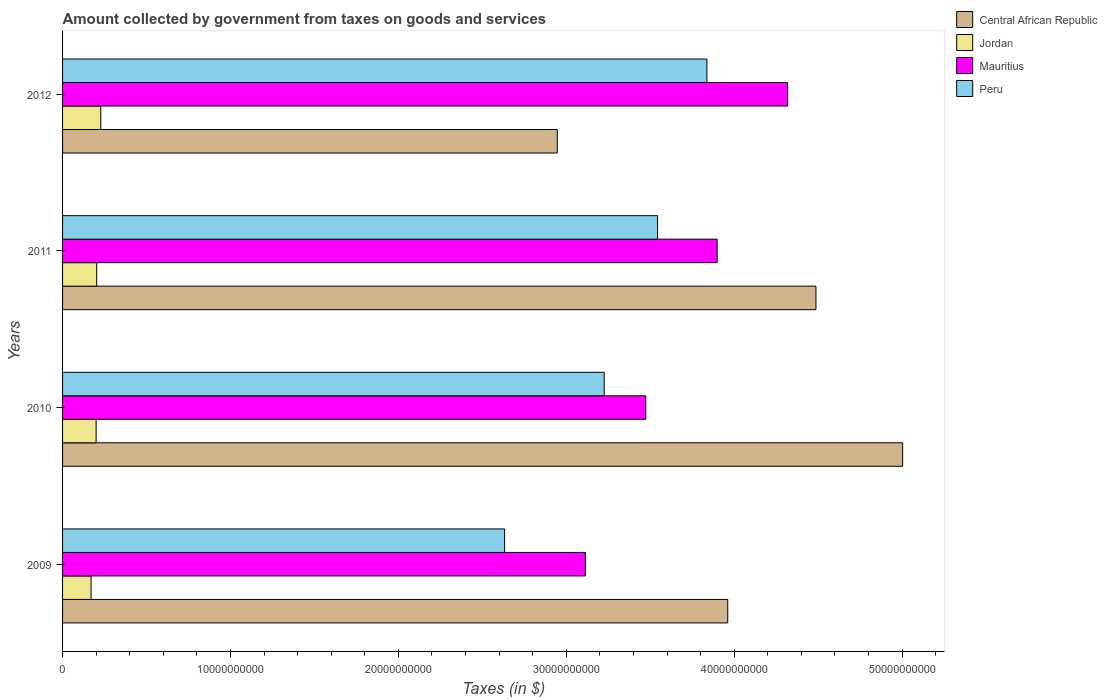Are the number of bars per tick equal to the number of legend labels?
Make the answer very short. Yes. How many bars are there on the 4th tick from the bottom?
Give a very brief answer. 4. In how many cases, is the number of bars for a given year not equal to the number of legend labels?
Your answer should be very brief. 0. What is the amount collected by government from taxes on goods and services in Jordan in 2011?
Provide a short and direct response. 2.03e+09. Across all years, what is the maximum amount collected by government from taxes on goods and services in Central African Republic?
Provide a short and direct response. 5.00e+1. Across all years, what is the minimum amount collected by government from taxes on goods and services in Peru?
Provide a short and direct response. 2.63e+1. What is the total amount collected by government from taxes on goods and services in Peru in the graph?
Keep it short and to the point. 1.32e+11. What is the difference between the amount collected by government from taxes on goods and services in Peru in 2010 and that in 2011?
Keep it short and to the point. -3.18e+09. What is the difference between the amount collected by government from taxes on goods and services in Jordan in 2010 and the amount collected by government from taxes on goods and services in Peru in 2009?
Provide a short and direct response. -2.43e+1. What is the average amount collected by government from taxes on goods and services in Mauritius per year?
Your answer should be compact. 3.70e+1. In the year 2012, what is the difference between the amount collected by government from taxes on goods and services in Central African Republic and amount collected by government from taxes on goods and services in Mauritius?
Your answer should be compact. -1.37e+1. What is the ratio of the amount collected by government from taxes on goods and services in Peru in 2010 to that in 2012?
Provide a succinct answer. 0.84. Is the amount collected by government from taxes on goods and services in Central African Republic in 2010 less than that in 2011?
Provide a succinct answer. No. Is the difference between the amount collected by government from taxes on goods and services in Central African Republic in 2011 and 2012 greater than the difference between the amount collected by government from taxes on goods and services in Mauritius in 2011 and 2012?
Your answer should be very brief. Yes. What is the difference between the highest and the second highest amount collected by government from taxes on goods and services in Mauritius?
Your answer should be very brief. 4.20e+09. What is the difference between the highest and the lowest amount collected by government from taxes on goods and services in Mauritius?
Your response must be concise. 1.20e+1. In how many years, is the amount collected by government from taxes on goods and services in Jordan greater than the average amount collected by government from taxes on goods and services in Jordan taken over all years?
Your answer should be compact. 2. Is the sum of the amount collected by government from taxes on goods and services in Central African Republic in 2010 and 2012 greater than the maximum amount collected by government from taxes on goods and services in Peru across all years?
Your answer should be very brief. Yes. Is it the case that in every year, the sum of the amount collected by government from taxes on goods and services in Mauritius and amount collected by government from taxes on goods and services in Jordan is greater than the sum of amount collected by government from taxes on goods and services in Peru and amount collected by government from taxes on goods and services in Central African Republic?
Offer a terse response. No. What does the 3rd bar from the bottom in 2012 represents?
Your response must be concise. Mauritius. Is it the case that in every year, the sum of the amount collected by government from taxes on goods and services in Peru and amount collected by government from taxes on goods and services in Central African Republic is greater than the amount collected by government from taxes on goods and services in Jordan?
Offer a very short reply. Yes. How many years are there in the graph?
Your response must be concise. 4. Are the values on the major ticks of X-axis written in scientific E-notation?
Make the answer very short. No. Does the graph contain any zero values?
Offer a terse response. No. Where does the legend appear in the graph?
Offer a very short reply. Top right. How many legend labels are there?
Your response must be concise. 4. How are the legend labels stacked?
Your response must be concise. Vertical. What is the title of the graph?
Ensure brevity in your answer.  Amount collected by government from taxes on goods and services. What is the label or title of the X-axis?
Make the answer very short. Taxes (in $). What is the label or title of the Y-axis?
Your answer should be very brief. Years. What is the Taxes (in $) in Central African Republic in 2009?
Provide a short and direct response. 3.96e+1. What is the Taxes (in $) in Jordan in 2009?
Offer a very short reply. 1.70e+09. What is the Taxes (in $) in Mauritius in 2009?
Offer a very short reply. 3.11e+1. What is the Taxes (in $) of Peru in 2009?
Keep it short and to the point. 2.63e+1. What is the Taxes (in $) of Central African Republic in 2010?
Ensure brevity in your answer.  5.00e+1. What is the Taxes (in $) in Jordan in 2010?
Offer a very short reply. 2.00e+09. What is the Taxes (in $) of Mauritius in 2010?
Your response must be concise. 3.47e+1. What is the Taxes (in $) in Peru in 2010?
Keep it short and to the point. 3.23e+1. What is the Taxes (in $) in Central African Republic in 2011?
Offer a terse response. 4.49e+1. What is the Taxes (in $) of Jordan in 2011?
Your answer should be compact. 2.03e+09. What is the Taxes (in $) of Mauritius in 2011?
Your answer should be very brief. 3.90e+1. What is the Taxes (in $) in Peru in 2011?
Offer a very short reply. 3.54e+1. What is the Taxes (in $) in Central African Republic in 2012?
Offer a very short reply. 2.95e+1. What is the Taxes (in $) in Jordan in 2012?
Your answer should be very brief. 2.27e+09. What is the Taxes (in $) of Mauritius in 2012?
Your answer should be very brief. 4.32e+1. What is the Taxes (in $) of Peru in 2012?
Your response must be concise. 3.84e+1. Across all years, what is the maximum Taxes (in $) in Central African Republic?
Provide a succinct answer. 5.00e+1. Across all years, what is the maximum Taxes (in $) in Jordan?
Provide a succinct answer. 2.27e+09. Across all years, what is the maximum Taxes (in $) of Mauritius?
Provide a short and direct response. 4.32e+1. Across all years, what is the maximum Taxes (in $) of Peru?
Make the answer very short. 3.84e+1. Across all years, what is the minimum Taxes (in $) in Central African Republic?
Provide a short and direct response. 2.95e+1. Across all years, what is the minimum Taxes (in $) in Jordan?
Give a very brief answer. 1.70e+09. Across all years, what is the minimum Taxes (in $) of Mauritius?
Your response must be concise. 3.11e+1. Across all years, what is the minimum Taxes (in $) in Peru?
Your response must be concise. 2.63e+1. What is the total Taxes (in $) of Central African Republic in the graph?
Your answer should be very brief. 1.64e+11. What is the total Taxes (in $) of Jordan in the graph?
Ensure brevity in your answer.  8.00e+09. What is the total Taxes (in $) in Mauritius in the graph?
Give a very brief answer. 1.48e+11. What is the total Taxes (in $) of Peru in the graph?
Your response must be concise. 1.32e+11. What is the difference between the Taxes (in $) in Central African Republic in 2009 and that in 2010?
Your response must be concise. -1.04e+1. What is the difference between the Taxes (in $) of Jordan in 2009 and that in 2010?
Ensure brevity in your answer.  -3.00e+08. What is the difference between the Taxes (in $) of Mauritius in 2009 and that in 2010?
Provide a short and direct response. -3.60e+09. What is the difference between the Taxes (in $) of Peru in 2009 and that in 2010?
Offer a terse response. -5.93e+09. What is the difference between the Taxes (in $) of Central African Republic in 2009 and that in 2011?
Provide a short and direct response. -5.25e+09. What is the difference between the Taxes (in $) of Jordan in 2009 and that in 2011?
Provide a short and direct response. -3.35e+08. What is the difference between the Taxes (in $) of Mauritius in 2009 and that in 2011?
Your answer should be very brief. -7.85e+09. What is the difference between the Taxes (in $) in Peru in 2009 and that in 2011?
Your answer should be compact. -9.11e+09. What is the difference between the Taxes (in $) in Central African Republic in 2009 and that in 2012?
Offer a terse response. 1.02e+1. What is the difference between the Taxes (in $) in Jordan in 2009 and that in 2012?
Ensure brevity in your answer.  -5.76e+08. What is the difference between the Taxes (in $) in Mauritius in 2009 and that in 2012?
Give a very brief answer. -1.20e+1. What is the difference between the Taxes (in $) of Peru in 2009 and that in 2012?
Keep it short and to the point. -1.20e+1. What is the difference between the Taxes (in $) in Central African Republic in 2010 and that in 2011?
Offer a very short reply. 5.16e+09. What is the difference between the Taxes (in $) of Jordan in 2010 and that in 2011?
Offer a very short reply. -3.53e+07. What is the difference between the Taxes (in $) of Mauritius in 2010 and that in 2011?
Make the answer very short. -4.25e+09. What is the difference between the Taxes (in $) of Peru in 2010 and that in 2011?
Ensure brevity in your answer.  -3.18e+09. What is the difference between the Taxes (in $) in Central African Republic in 2010 and that in 2012?
Keep it short and to the point. 2.06e+1. What is the difference between the Taxes (in $) in Jordan in 2010 and that in 2012?
Make the answer very short. -2.77e+08. What is the difference between the Taxes (in $) in Mauritius in 2010 and that in 2012?
Your answer should be compact. -8.45e+09. What is the difference between the Taxes (in $) in Peru in 2010 and that in 2012?
Your response must be concise. -6.12e+09. What is the difference between the Taxes (in $) of Central African Republic in 2011 and that in 2012?
Ensure brevity in your answer.  1.54e+1. What is the difference between the Taxes (in $) in Jordan in 2011 and that in 2012?
Your answer should be very brief. -2.42e+08. What is the difference between the Taxes (in $) of Mauritius in 2011 and that in 2012?
Your response must be concise. -4.20e+09. What is the difference between the Taxes (in $) of Peru in 2011 and that in 2012?
Offer a terse response. -2.94e+09. What is the difference between the Taxes (in $) in Central African Republic in 2009 and the Taxes (in $) in Jordan in 2010?
Ensure brevity in your answer.  3.76e+1. What is the difference between the Taxes (in $) in Central African Republic in 2009 and the Taxes (in $) in Mauritius in 2010?
Provide a succinct answer. 4.88e+09. What is the difference between the Taxes (in $) in Central African Republic in 2009 and the Taxes (in $) in Peru in 2010?
Your answer should be very brief. 7.36e+09. What is the difference between the Taxes (in $) in Jordan in 2009 and the Taxes (in $) in Mauritius in 2010?
Offer a very short reply. -3.30e+1. What is the difference between the Taxes (in $) of Jordan in 2009 and the Taxes (in $) of Peru in 2010?
Offer a terse response. -3.06e+1. What is the difference between the Taxes (in $) in Mauritius in 2009 and the Taxes (in $) in Peru in 2010?
Provide a succinct answer. -1.12e+09. What is the difference between the Taxes (in $) of Central African Republic in 2009 and the Taxes (in $) of Jordan in 2011?
Your response must be concise. 3.76e+1. What is the difference between the Taxes (in $) of Central African Republic in 2009 and the Taxes (in $) of Mauritius in 2011?
Your answer should be compact. 6.32e+08. What is the difference between the Taxes (in $) in Central African Republic in 2009 and the Taxes (in $) in Peru in 2011?
Offer a terse response. 4.18e+09. What is the difference between the Taxes (in $) of Jordan in 2009 and the Taxes (in $) of Mauritius in 2011?
Offer a very short reply. -3.73e+1. What is the difference between the Taxes (in $) in Jordan in 2009 and the Taxes (in $) in Peru in 2011?
Give a very brief answer. -3.37e+1. What is the difference between the Taxes (in $) in Mauritius in 2009 and the Taxes (in $) in Peru in 2011?
Give a very brief answer. -4.30e+09. What is the difference between the Taxes (in $) in Central African Republic in 2009 and the Taxes (in $) in Jordan in 2012?
Your response must be concise. 3.73e+1. What is the difference between the Taxes (in $) in Central African Republic in 2009 and the Taxes (in $) in Mauritius in 2012?
Your answer should be very brief. -3.57e+09. What is the difference between the Taxes (in $) in Central African Republic in 2009 and the Taxes (in $) in Peru in 2012?
Offer a very short reply. 1.24e+09. What is the difference between the Taxes (in $) in Jordan in 2009 and the Taxes (in $) in Mauritius in 2012?
Provide a short and direct response. -4.15e+1. What is the difference between the Taxes (in $) in Jordan in 2009 and the Taxes (in $) in Peru in 2012?
Offer a terse response. -3.67e+1. What is the difference between the Taxes (in $) in Mauritius in 2009 and the Taxes (in $) in Peru in 2012?
Give a very brief answer. -7.24e+09. What is the difference between the Taxes (in $) in Central African Republic in 2010 and the Taxes (in $) in Jordan in 2011?
Provide a short and direct response. 4.80e+1. What is the difference between the Taxes (in $) in Central African Republic in 2010 and the Taxes (in $) in Mauritius in 2011?
Offer a very short reply. 1.10e+1. What is the difference between the Taxes (in $) of Central African Republic in 2010 and the Taxes (in $) of Peru in 2011?
Provide a short and direct response. 1.46e+1. What is the difference between the Taxes (in $) of Jordan in 2010 and the Taxes (in $) of Mauritius in 2011?
Make the answer very short. -3.70e+1. What is the difference between the Taxes (in $) of Jordan in 2010 and the Taxes (in $) of Peru in 2011?
Keep it short and to the point. -3.34e+1. What is the difference between the Taxes (in $) of Mauritius in 2010 and the Taxes (in $) of Peru in 2011?
Give a very brief answer. -7.03e+08. What is the difference between the Taxes (in $) in Central African Republic in 2010 and the Taxes (in $) in Jordan in 2012?
Provide a short and direct response. 4.78e+1. What is the difference between the Taxes (in $) in Central African Republic in 2010 and the Taxes (in $) in Mauritius in 2012?
Give a very brief answer. 6.85e+09. What is the difference between the Taxes (in $) in Central African Republic in 2010 and the Taxes (in $) in Peru in 2012?
Provide a succinct answer. 1.17e+1. What is the difference between the Taxes (in $) in Jordan in 2010 and the Taxes (in $) in Mauritius in 2012?
Give a very brief answer. -4.12e+1. What is the difference between the Taxes (in $) in Jordan in 2010 and the Taxes (in $) in Peru in 2012?
Your answer should be very brief. -3.64e+1. What is the difference between the Taxes (in $) of Mauritius in 2010 and the Taxes (in $) of Peru in 2012?
Keep it short and to the point. -3.64e+09. What is the difference between the Taxes (in $) in Central African Republic in 2011 and the Taxes (in $) in Jordan in 2012?
Offer a terse response. 4.26e+1. What is the difference between the Taxes (in $) of Central African Republic in 2011 and the Taxes (in $) of Mauritius in 2012?
Give a very brief answer. 1.68e+09. What is the difference between the Taxes (in $) of Central African Republic in 2011 and the Taxes (in $) of Peru in 2012?
Offer a terse response. 6.49e+09. What is the difference between the Taxes (in $) in Jordan in 2011 and the Taxes (in $) in Mauritius in 2012?
Keep it short and to the point. -4.12e+1. What is the difference between the Taxes (in $) in Jordan in 2011 and the Taxes (in $) in Peru in 2012?
Make the answer very short. -3.63e+1. What is the difference between the Taxes (in $) in Mauritius in 2011 and the Taxes (in $) in Peru in 2012?
Your answer should be very brief. 6.09e+08. What is the average Taxes (in $) in Central African Republic per year?
Make the answer very short. 4.10e+1. What is the average Taxes (in $) of Jordan per year?
Give a very brief answer. 2.00e+09. What is the average Taxes (in $) of Mauritius per year?
Give a very brief answer. 3.70e+1. What is the average Taxes (in $) of Peru per year?
Give a very brief answer. 3.31e+1. In the year 2009, what is the difference between the Taxes (in $) in Central African Republic and Taxes (in $) in Jordan?
Your answer should be very brief. 3.79e+1. In the year 2009, what is the difference between the Taxes (in $) in Central African Republic and Taxes (in $) in Mauritius?
Ensure brevity in your answer.  8.48e+09. In the year 2009, what is the difference between the Taxes (in $) in Central African Republic and Taxes (in $) in Peru?
Your answer should be compact. 1.33e+1. In the year 2009, what is the difference between the Taxes (in $) of Jordan and Taxes (in $) of Mauritius?
Your response must be concise. -2.94e+1. In the year 2009, what is the difference between the Taxes (in $) of Jordan and Taxes (in $) of Peru?
Provide a short and direct response. -2.46e+1. In the year 2009, what is the difference between the Taxes (in $) in Mauritius and Taxes (in $) in Peru?
Your answer should be very brief. 4.81e+09. In the year 2010, what is the difference between the Taxes (in $) of Central African Republic and Taxes (in $) of Jordan?
Keep it short and to the point. 4.80e+1. In the year 2010, what is the difference between the Taxes (in $) of Central African Republic and Taxes (in $) of Mauritius?
Make the answer very short. 1.53e+1. In the year 2010, what is the difference between the Taxes (in $) in Central African Republic and Taxes (in $) in Peru?
Make the answer very short. 1.78e+1. In the year 2010, what is the difference between the Taxes (in $) in Jordan and Taxes (in $) in Mauritius?
Ensure brevity in your answer.  -3.27e+1. In the year 2010, what is the difference between the Taxes (in $) in Jordan and Taxes (in $) in Peru?
Provide a short and direct response. -3.03e+1. In the year 2010, what is the difference between the Taxes (in $) of Mauritius and Taxes (in $) of Peru?
Provide a short and direct response. 2.47e+09. In the year 2011, what is the difference between the Taxes (in $) of Central African Republic and Taxes (in $) of Jordan?
Your response must be concise. 4.28e+1. In the year 2011, what is the difference between the Taxes (in $) in Central African Republic and Taxes (in $) in Mauritius?
Give a very brief answer. 5.88e+09. In the year 2011, what is the difference between the Taxes (in $) in Central African Republic and Taxes (in $) in Peru?
Keep it short and to the point. 9.43e+09. In the year 2011, what is the difference between the Taxes (in $) of Jordan and Taxes (in $) of Mauritius?
Your answer should be compact. -3.69e+1. In the year 2011, what is the difference between the Taxes (in $) of Jordan and Taxes (in $) of Peru?
Offer a very short reply. -3.34e+1. In the year 2011, what is the difference between the Taxes (in $) in Mauritius and Taxes (in $) in Peru?
Provide a succinct answer. 3.55e+09. In the year 2012, what is the difference between the Taxes (in $) in Central African Republic and Taxes (in $) in Jordan?
Offer a terse response. 2.72e+1. In the year 2012, what is the difference between the Taxes (in $) in Central African Republic and Taxes (in $) in Mauritius?
Your answer should be very brief. -1.37e+1. In the year 2012, what is the difference between the Taxes (in $) in Central African Republic and Taxes (in $) in Peru?
Give a very brief answer. -8.91e+09. In the year 2012, what is the difference between the Taxes (in $) in Jordan and Taxes (in $) in Mauritius?
Make the answer very short. -4.09e+1. In the year 2012, what is the difference between the Taxes (in $) of Jordan and Taxes (in $) of Peru?
Provide a succinct answer. -3.61e+1. In the year 2012, what is the difference between the Taxes (in $) in Mauritius and Taxes (in $) in Peru?
Your answer should be compact. 4.81e+09. What is the ratio of the Taxes (in $) in Central African Republic in 2009 to that in 2010?
Make the answer very short. 0.79. What is the ratio of the Taxes (in $) of Jordan in 2009 to that in 2010?
Your response must be concise. 0.85. What is the ratio of the Taxes (in $) of Mauritius in 2009 to that in 2010?
Give a very brief answer. 0.9. What is the ratio of the Taxes (in $) of Peru in 2009 to that in 2010?
Your response must be concise. 0.82. What is the ratio of the Taxes (in $) in Central African Republic in 2009 to that in 2011?
Your response must be concise. 0.88. What is the ratio of the Taxes (in $) in Jordan in 2009 to that in 2011?
Offer a very short reply. 0.84. What is the ratio of the Taxes (in $) of Mauritius in 2009 to that in 2011?
Ensure brevity in your answer.  0.8. What is the ratio of the Taxes (in $) in Peru in 2009 to that in 2011?
Your answer should be compact. 0.74. What is the ratio of the Taxes (in $) in Central African Republic in 2009 to that in 2012?
Make the answer very short. 1.34. What is the ratio of the Taxes (in $) in Jordan in 2009 to that in 2012?
Keep it short and to the point. 0.75. What is the ratio of the Taxes (in $) of Mauritius in 2009 to that in 2012?
Your answer should be compact. 0.72. What is the ratio of the Taxes (in $) in Peru in 2009 to that in 2012?
Your response must be concise. 0.69. What is the ratio of the Taxes (in $) of Central African Republic in 2010 to that in 2011?
Your answer should be compact. 1.12. What is the ratio of the Taxes (in $) of Jordan in 2010 to that in 2011?
Make the answer very short. 0.98. What is the ratio of the Taxes (in $) in Mauritius in 2010 to that in 2011?
Your answer should be very brief. 0.89. What is the ratio of the Taxes (in $) of Peru in 2010 to that in 2011?
Offer a terse response. 0.91. What is the ratio of the Taxes (in $) of Central African Republic in 2010 to that in 2012?
Your answer should be very brief. 1.7. What is the ratio of the Taxes (in $) in Jordan in 2010 to that in 2012?
Make the answer very short. 0.88. What is the ratio of the Taxes (in $) of Mauritius in 2010 to that in 2012?
Provide a succinct answer. 0.8. What is the ratio of the Taxes (in $) in Peru in 2010 to that in 2012?
Provide a short and direct response. 0.84. What is the ratio of the Taxes (in $) in Central African Republic in 2011 to that in 2012?
Provide a short and direct response. 1.52. What is the ratio of the Taxes (in $) in Jordan in 2011 to that in 2012?
Offer a terse response. 0.89. What is the ratio of the Taxes (in $) in Mauritius in 2011 to that in 2012?
Your answer should be very brief. 0.9. What is the ratio of the Taxes (in $) of Peru in 2011 to that in 2012?
Make the answer very short. 0.92. What is the difference between the highest and the second highest Taxes (in $) of Central African Republic?
Your answer should be compact. 5.16e+09. What is the difference between the highest and the second highest Taxes (in $) in Jordan?
Your answer should be compact. 2.42e+08. What is the difference between the highest and the second highest Taxes (in $) in Mauritius?
Make the answer very short. 4.20e+09. What is the difference between the highest and the second highest Taxes (in $) of Peru?
Give a very brief answer. 2.94e+09. What is the difference between the highest and the lowest Taxes (in $) of Central African Republic?
Give a very brief answer. 2.06e+1. What is the difference between the highest and the lowest Taxes (in $) of Jordan?
Make the answer very short. 5.76e+08. What is the difference between the highest and the lowest Taxes (in $) in Mauritius?
Provide a short and direct response. 1.20e+1. What is the difference between the highest and the lowest Taxes (in $) in Peru?
Your answer should be compact. 1.20e+1. 